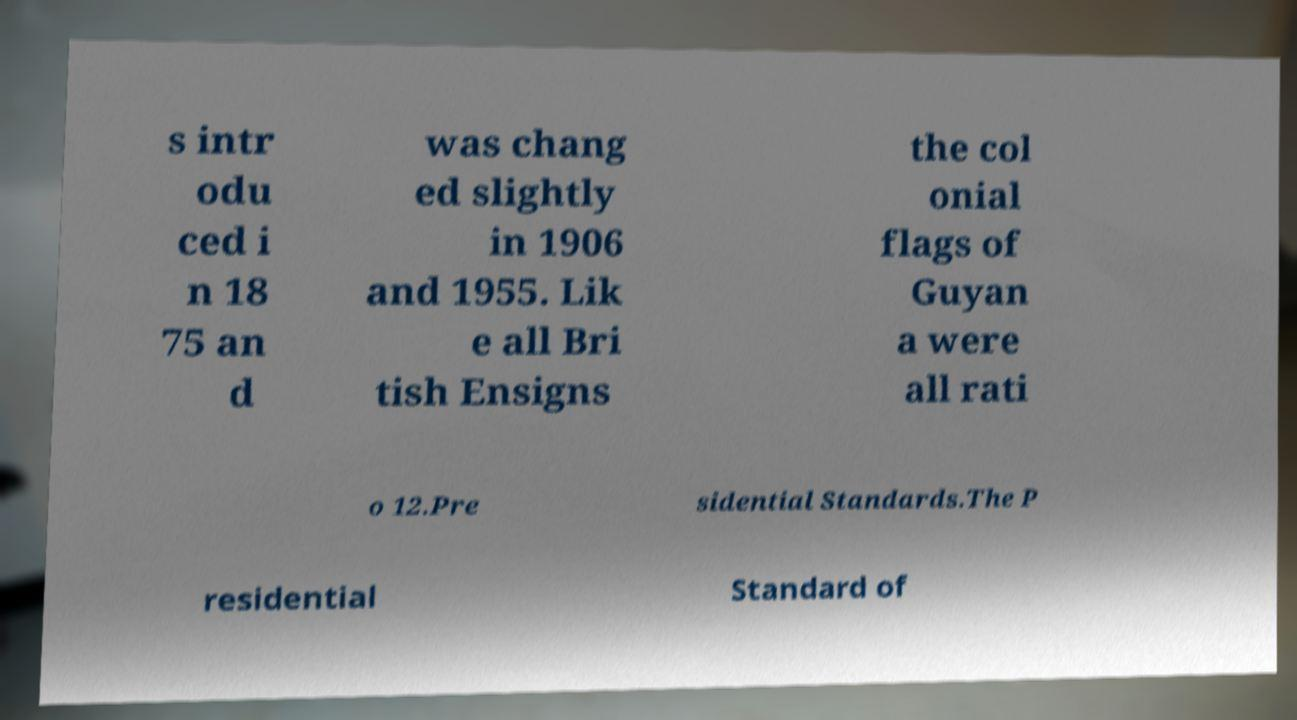Could you extract and type out the text from this image? s intr odu ced i n 18 75 an d was chang ed slightly in 1906 and 1955. Lik e all Bri tish Ensigns the col onial flags of Guyan a were all rati o 12.Pre sidential Standards.The P residential Standard of 